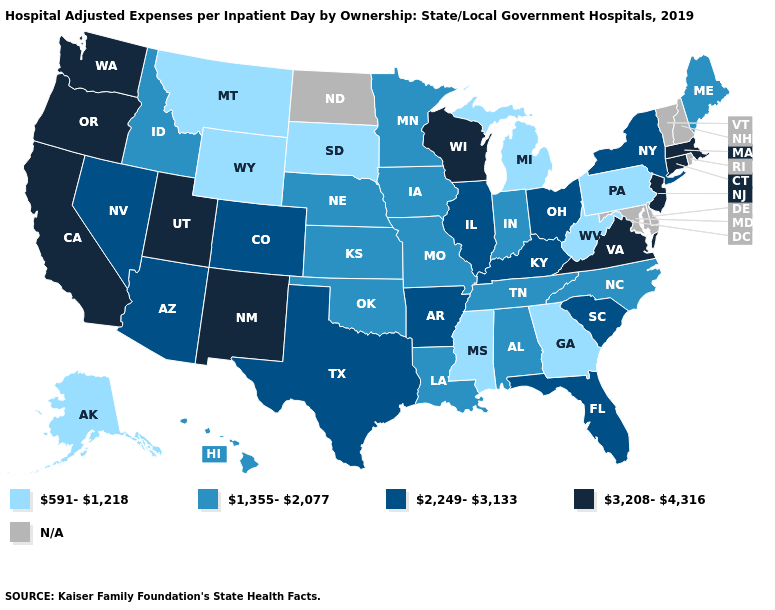What is the value of Minnesota?
Concise answer only. 1,355-2,077. Name the states that have a value in the range N/A?
Be succinct. Delaware, Maryland, New Hampshire, North Dakota, Rhode Island, Vermont. What is the value of Maine?
Concise answer only. 1,355-2,077. Which states have the highest value in the USA?
Quick response, please. California, Connecticut, Massachusetts, New Jersey, New Mexico, Oregon, Utah, Virginia, Washington, Wisconsin. What is the value of Tennessee?
Write a very short answer. 1,355-2,077. What is the value of Virginia?
Write a very short answer. 3,208-4,316. Does Pennsylvania have the lowest value in the USA?
Answer briefly. Yes. Name the states that have a value in the range 2,249-3,133?
Give a very brief answer. Arizona, Arkansas, Colorado, Florida, Illinois, Kentucky, Nevada, New York, Ohio, South Carolina, Texas. Name the states that have a value in the range N/A?
Give a very brief answer. Delaware, Maryland, New Hampshire, North Dakota, Rhode Island, Vermont. Among the states that border Oregon , which have the highest value?
Quick response, please. California, Washington. Does the first symbol in the legend represent the smallest category?
Give a very brief answer. Yes. What is the lowest value in the USA?
Be succinct. 591-1,218. Among the states that border New Mexico , does Arizona have the lowest value?
Be succinct. No. Name the states that have a value in the range 591-1,218?
Give a very brief answer. Alaska, Georgia, Michigan, Mississippi, Montana, Pennsylvania, South Dakota, West Virginia, Wyoming. 